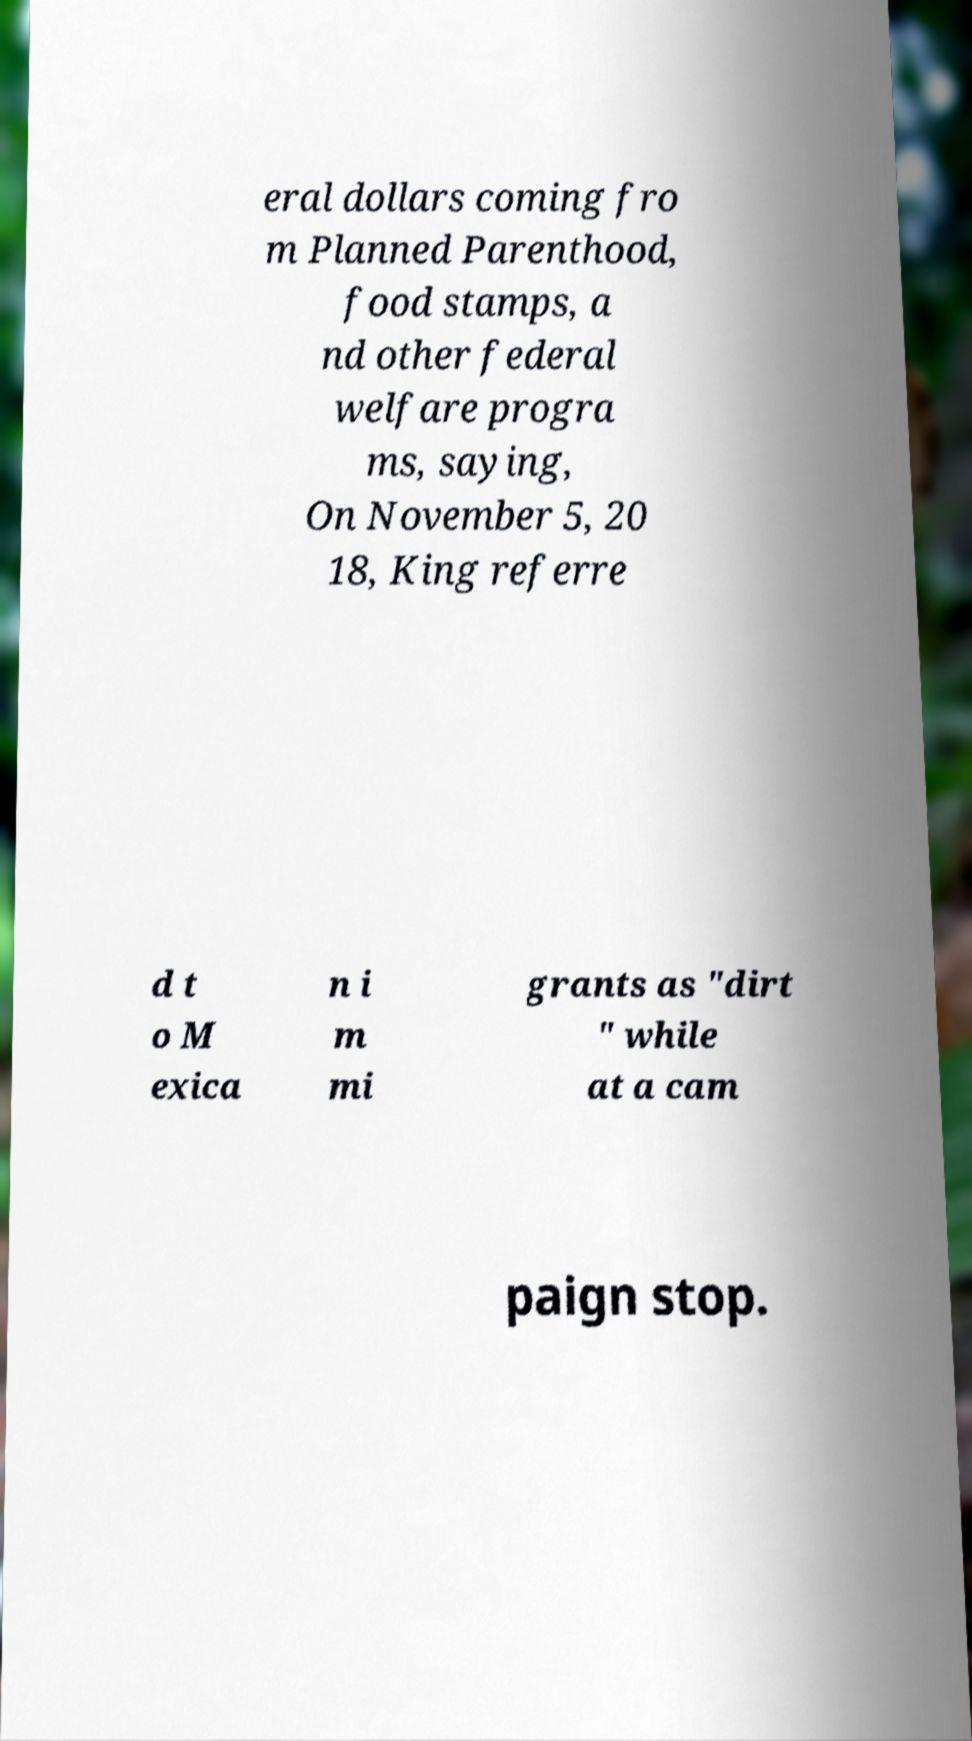Can you read and provide the text displayed in the image?This photo seems to have some interesting text. Can you extract and type it out for me? eral dollars coming fro m Planned Parenthood, food stamps, a nd other federal welfare progra ms, saying, On November 5, 20 18, King referre d t o M exica n i m mi grants as "dirt " while at a cam paign stop. 